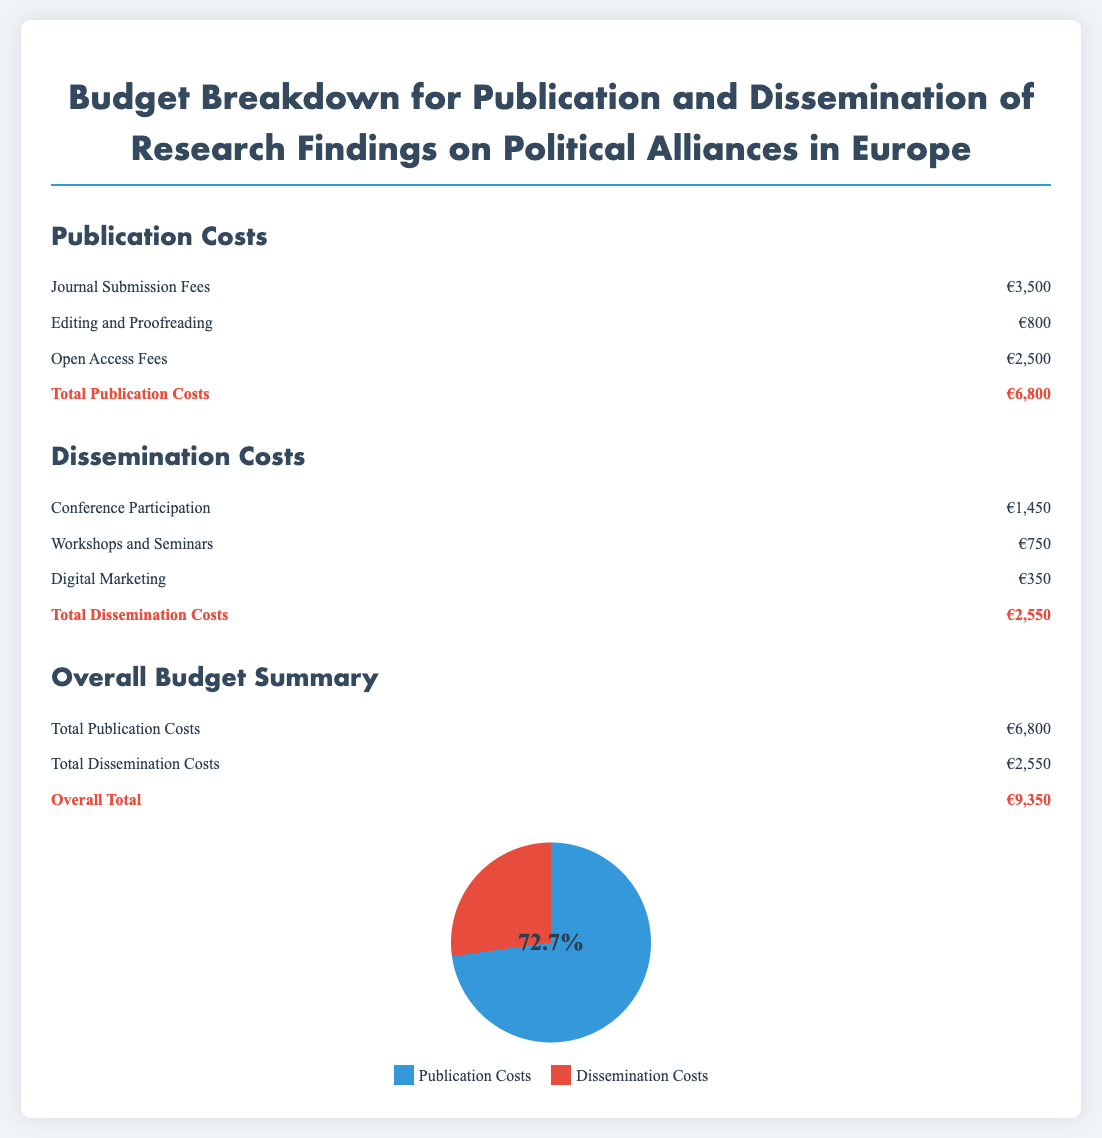What is the total publication cost? The total publication cost is the sum of all publication-related expenses detailed in the document, which equals €3,500 + €800 + €2,500.
Answer: €6,800 What is the amount allocated for conference participation? The amount allocated for conference participation is specified under dissemination costs as €1,450.
Answer: €1,450 What percentage of the total budget is dedicated to publication costs? The total budget is €9,350, and the publication costs are €6,800. To find the percentage, we calculate (€6,800 / €9,350) * 100, which equals approximately 72.7%.
Answer: 72.7% What are the total dissemination costs? The total dissemination costs are reached by adding together all individual dissemination costs: €1,450 + €750 + €350.
Answer: €2,550 What expenses contribute to the editing and proofreading category? The editing and proofreading category includes one specific item listed as €800.
Answer: €800 Which category has a lower total cost: publication or dissemination? The total costs for publication and dissemination are €6,800 and €2,550, respectively. Since €2,550 is less than €6,800, dissemination costs are lower.
Answer: Dissemination What does the pie chart represent in the budget breakdown? The pie chart visually represents the proportion of total costs dedicated to publication versus dissemination in the budget breakdown.
Answer: Proportions of publication and dissemination costs How much is spent on digital marketing? The amount spent on digital marketing is specifically listed in the dissemination costs section as €350.
Answer: €350 